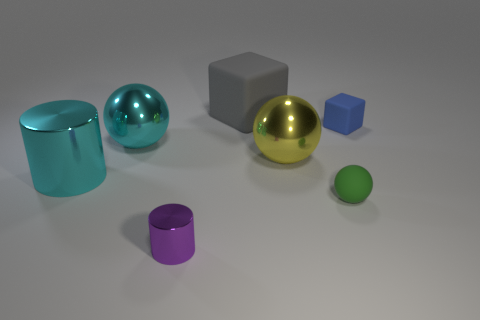Are the large ball in front of the large cyan metallic sphere and the large cyan thing to the right of the big metallic cylinder made of the same material?
Provide a short and direct response. Yes. Is the number of large objects greater than the number of big yellow rubber cylinders?
Provide a succinct answer. Yes. Are there any other things that are the same color as the big cylinder?
Your response must be concise. Yes. Is the tiny purple object made of the same material as the green sphere?
Offer a terse response. No. Is the number of tiny cylinders less than the number of cyan metal objects?
Provide a short and direct response. Yes. Does the large yellow thing have the same shape as the green matte thing?
Offer a very short reply. Yes. What is the color of the small metal cylinder?
Make the answer very short. Purple. How many other objects are there of the same material as the small blue object?
Offer a very short reply. 2. How many yellow objects are either matte cubes or tiny things?
Provide a short and direct response. 0. There is a tiny thing that is to the right of the small rubber sphere; does it have the same shape as the thing behind the tiny cube?
Make the answer very short. Yes. 